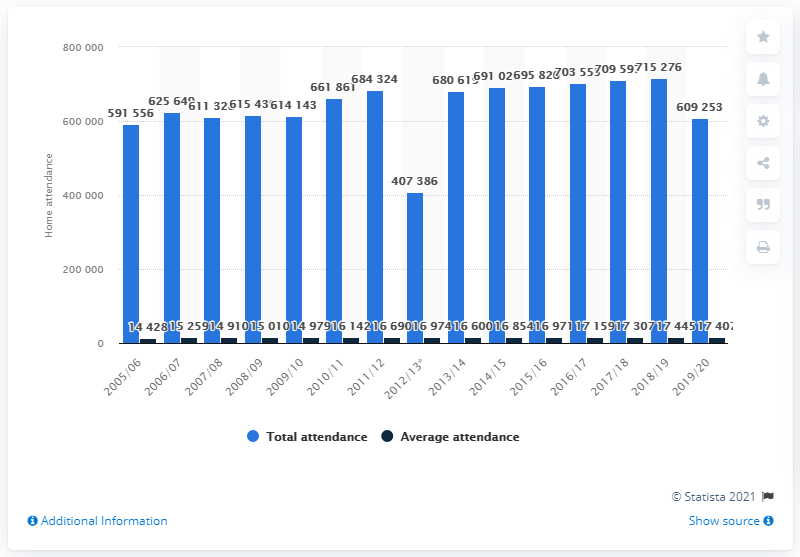Outline some significant characteristics in this image. The last season of the Nashville Predators in the National Hockey League was in 2005/2006. 